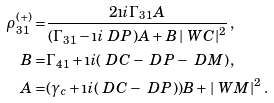Convert formula to latex. <formula><loc_0><loc_0><loc_500><loc_500>\rho _ { 3 1 } ^ { ( + ) } = & \frac { 2 \i i \Gamma _ { 3 1 } A } { ( \Gamma _ { 3 1 } - \i i \ D P ) A + B \left | \ W C \right | ^ { 2 } } \, , \\ B = & \Gamma _ { 4 1 } + \i i ( \ D C - \ D P - \ D M ) \, , \\ A = & ( \gamma _ { c } + \i i ( \ D C - \ D P ) ) B + \left | \ W M \right | ^ { 2 } \, .</formula> 